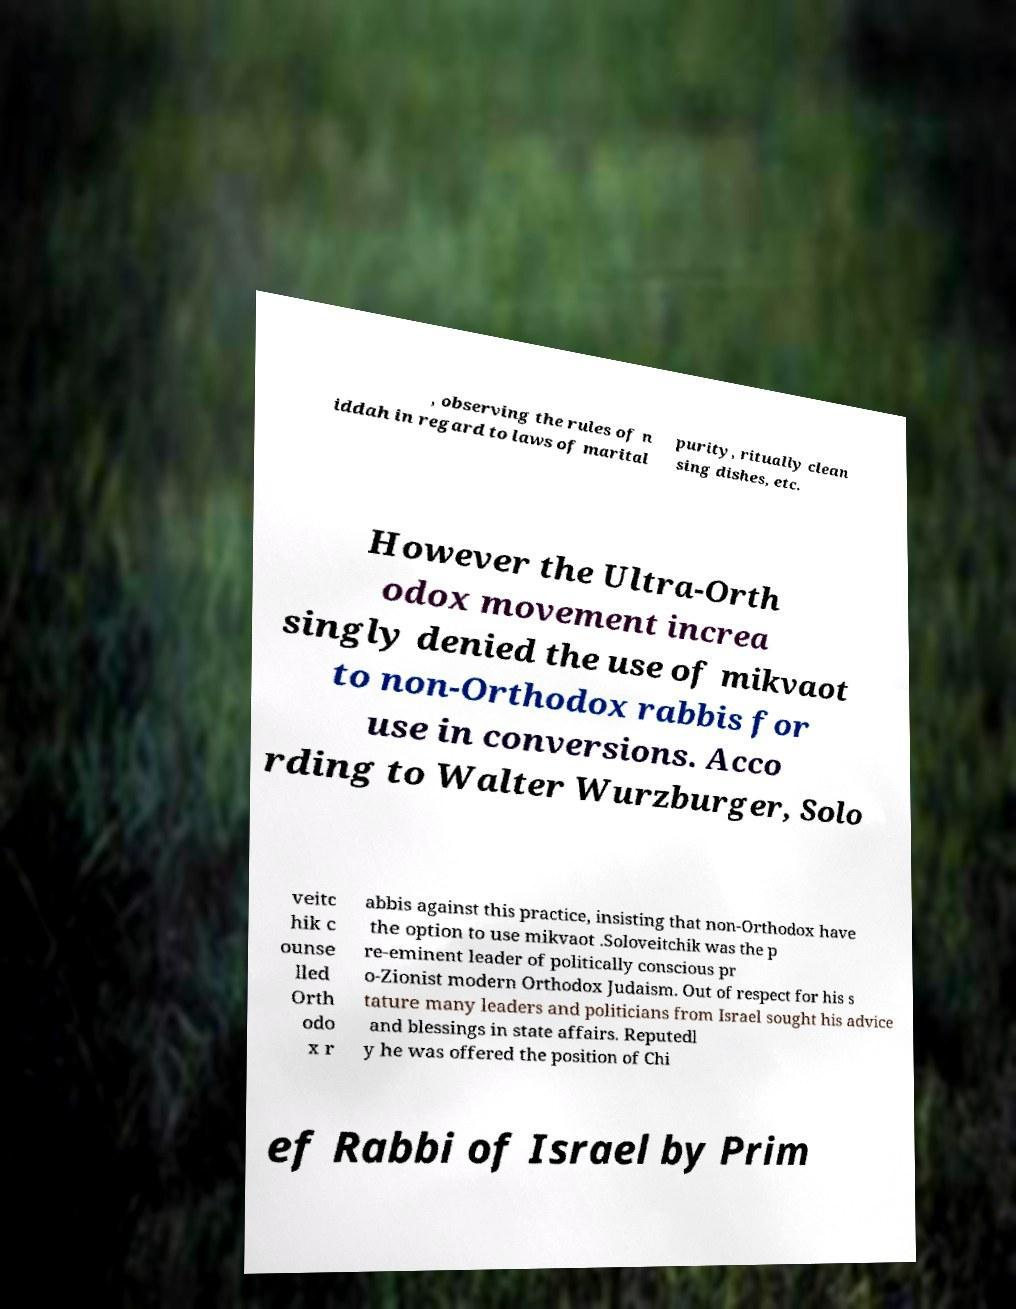I need the written content from this picture converted into text. Can you do that? , observing the rules of n iddah in regard to laws of marital purity, ritually clean sing dishes, etc. However the Ultra-Orth odox movement increa singly denied the use of mikvaot to non-Orthodox rabbis for use in conversions. Acco rding to Walter Wurzburger, Solo veitc hik c ounse lled Orth odo x r abbis against this practice, insisting that non-Orthodox have the option to use mikvaot .Soloveitchik was the p re-eminent leader of politically conscious pr o-Zionist modern Orthodox Judaism. Out of respect for his s tature many leaders and politicians from Israel sought his advice and blessings in state affairs. Reputedl y he was offered the position of Chi ef Rabbi of Israel by Prim 